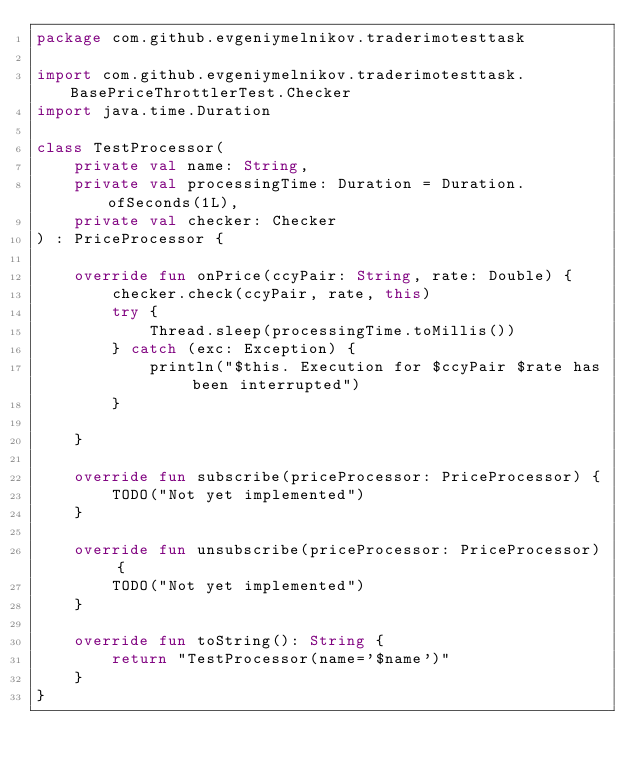Convert code to text. <code><loc_0><loc_0><loc_500><loc_500><_Kotlin_>package com.github.evgeniymelnikov.traderimotesttask

import com.github.evgeniymelnikov.traderimotesttask.BasePriceThrottlerTest.Checker
import java.time.Duration

class TestProcessor(
    private val name: String,
    private val processingTime: Duration = Duration.ofSeconds(1L),
    private val checker: Checker
) : PriceProcessor {

    override fun onPrice(ccyPair: String, rate: Double) {
        checker.check(ccyPair, rate, this)
        try {
            Thread.sleep(processingTime.toMillis())
        } catch (exc: Exception) {
            println("$this. Execution for $ccyPair $rate has been interrupted")
        }

    }

    override fun subscribe(priceProcessor: PriceProcessor) {
        TODO("Not yet implemented")
    }

    override fun unsubscribe(priceProcessor: PriceProcessor) {
        TODO("Not yet implemented")
    }

    override fun toString(): String {
        return "TestProcessor(name='$name')"
    }
}</code> 